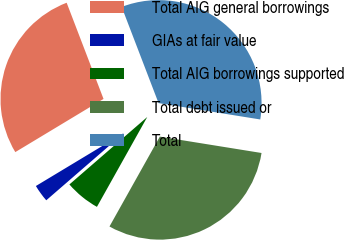Convert chart. <chart><loc_0><loc_0><loc_500><loc_500><pie_chart><fcel>Total AIG general borrowings<fcel>GIAs at fair value<fcel>Total AIG borrowings supported<fcel>Total debt issued or<fcel>Total<nl><fcel>27.8%<fcel>2.73%<fcel>5.51%<fcel>30.58%<fcel>33.36%<nl></chart> 